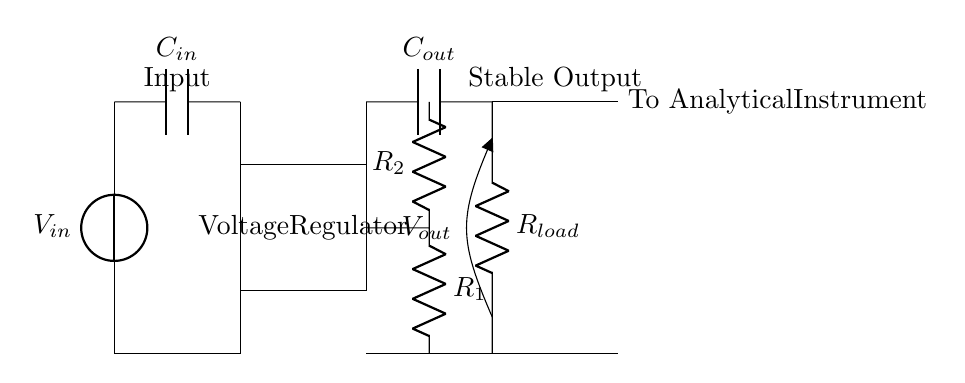What is the input source voltage? The circuit diagram uses a voltage source labeled as V_in. The specific voltage is not provided, but it is typically a DC input voltage to start the regulation process.
Answer: V_in What type of component is used for voltage regulation? The circuit diagram depicts a rectangular box labeled "Voltage Regulator." This indicates that an integrated circuit is used to convert the input voltage into a stable output voltage.
Answer: Voltage Regulator How many capacitors are present in the circuit? The circuit includes two capacitors, one labeled C_in and the other C_out, serving as input and output capacitors respectively.
Answer: 2 What is the function of the output resistor? The output resistor, labeled R_load, acts as a load for the voltage regulator, providing the necessary resistance for the circuit to operate and to measure the output voltage.
Answer: Load resistor What determines the output voltage in this circuit? The output voltage, denoted as V_out, is determined by the voltage regulator's feedback mechanism, which includes resistors labeled R_1 and R_2. These resistors set the output voltage based on their values.
Answer: R_1 and R_2 What do the labels "Input" and "Stable Output" indicate? The label "Input" refers to the point where the incoming voltage is applied, while "Stable Output" indicates the point where the regulated and stable voltage is provided to the analytical instrument.
Answer: Input and Stable Output What type of circuit is illustrated by this diagram? The circuit is a voltage regulator circuit designed to maintain a stable power supply, specifically tailored for sensitive analytical instruments that require consistent voltage levels.
Answer: Voltage regulator circuit 